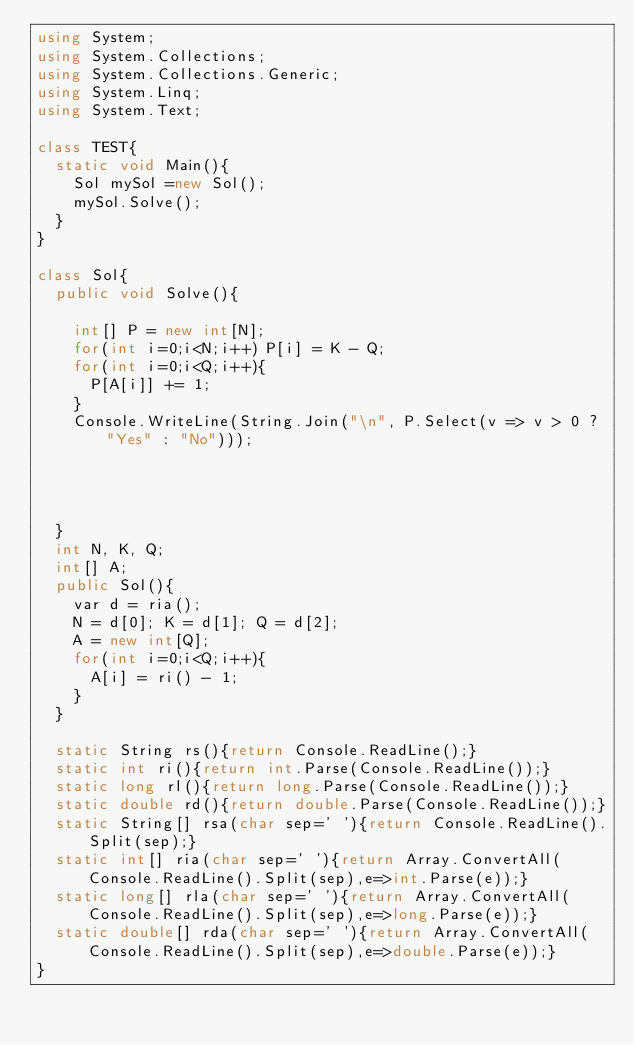Convert code to text. <code><loc_0><loc_0><loc_500><loc_500><_C#_>using System;
using System.Collections;
using System.Collections.Generic;
using System.Linq;
using System.Text;

class TEST{
	static void Main(){
		Sol mySol =new Sol();
		mySol.Solve();
	}
}

class Sol{
	public void Solve(){
		
		int[] P = new int[N];
		for(int i=0;i<N;i++) P[i] = K - Q;
		for(int i=0;i<Q;i++){
			P[A[i]] += 1;
		}
		Console.WriteLine(String.Join("\n", P.Select(v => v > 0 ? "Yes" : "No")));
		
		
		
		
	}
	int N, K, Q;
	int[] A;
	public Sol(){
		var d = ria();
		N = d[0]; K = d[1]; Q = d[2];
		A = new int[Q];
		for(int i=0;i<Q;i++){
			A[i] = ri() - 1;
		}
	}

	static String rs(){return Console.ReadLine();}
	static int ri(){return int.Parse(Console.ReadLine());}
	static long rl(){return long.Parse(Console.ReadLine());}
	static double rd(){return double.Parse(Console.ReadLine());}
	static String[] rsa(char sep=' '){return Console.ReadLine().Split(sep);}
	static int[] ria(char sep=' '){return Array.ConvertAll(Console.ReadLine().Split(sep),e=>int.Parse(e));}
	static long[] rla(char sep=' '){return Array.ConvertAll(Console.ReadLine().Split(sep),e=>long.Parse(e));}
	static double[] rda(char sep=' '){return Array.ConvertAll(Console.ReadLine().Split(sep),e=>double.Parse(e));}
}
</code> 